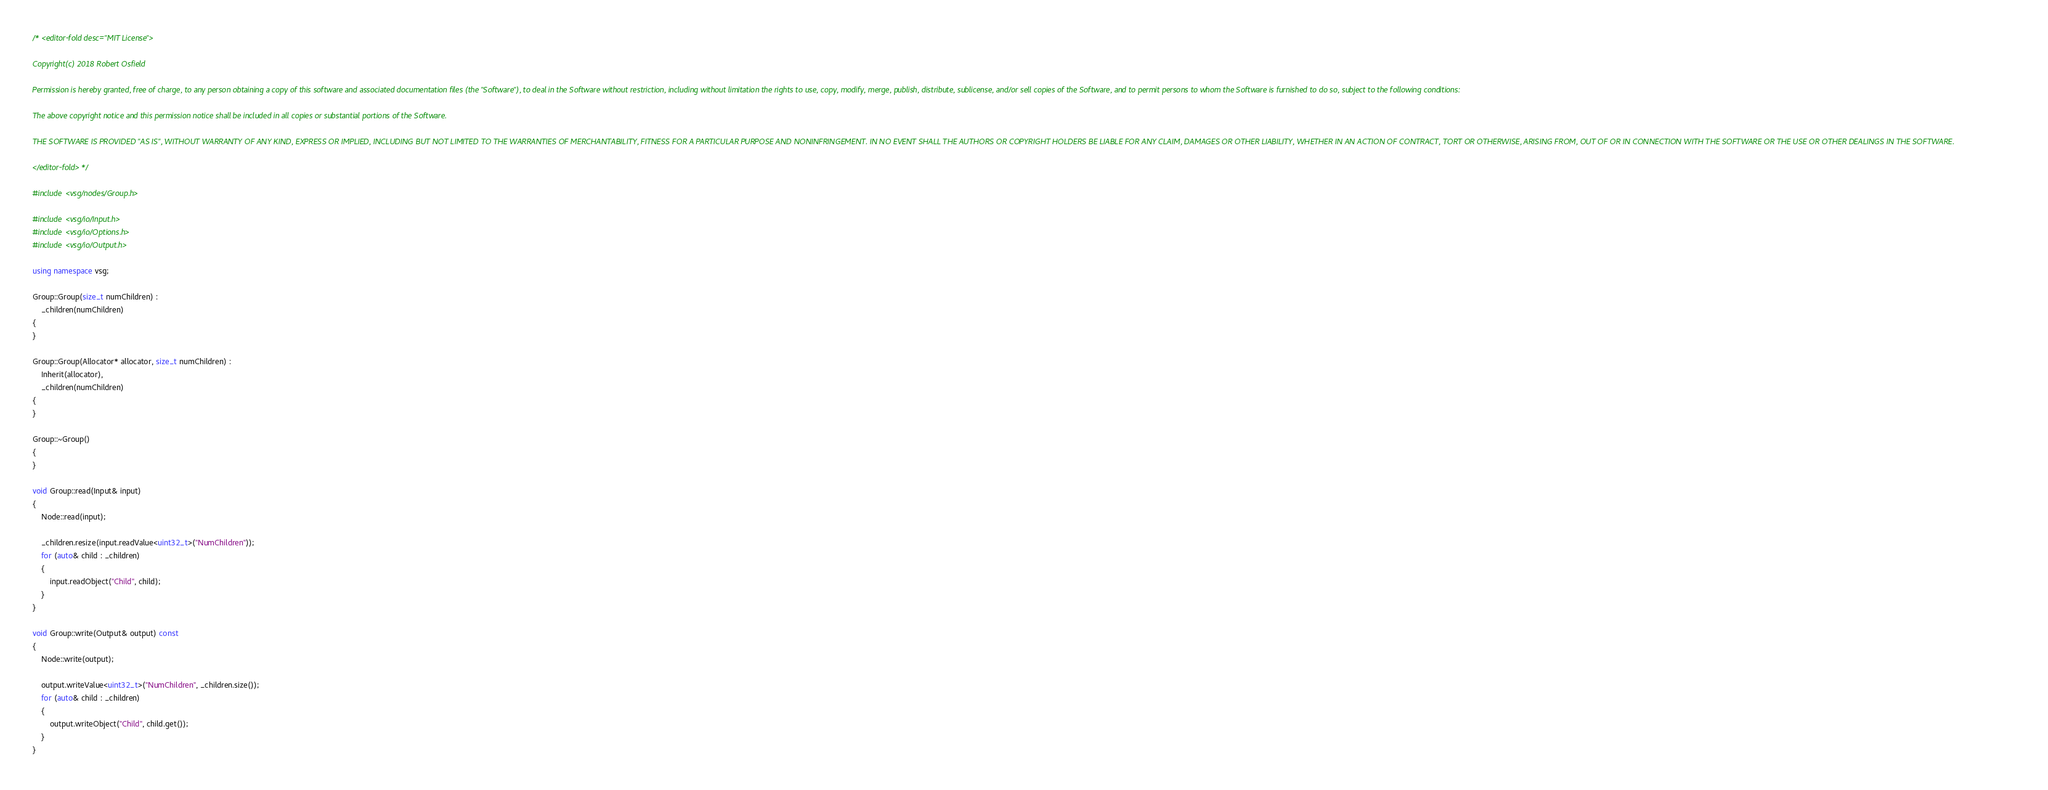<code> <loc_0><loc_0><loc_500><loc_500><_C++_>/* <editor-fold desc="MIT License">

Copyright(c) 2018 Robert Osfield

Permission is hereby granted, free of charge, to any person obtaining a copy of this software and associated documentation files (the "Software"), to deal in the Software without restriction, including without limitation the rights to use, copy, modify, merge, publish, distribute, sublicense, and/or sell copies of the Software, and to permit persons to whom the Software is furnished to do so, subject to the following conditions:

The above copyright notice and this permission notice shall be included in all copies or substantial portions of the Software.

THE SOFTWARE IS PROVIDED "AS IS", WITHOUT WARRANTY OF ANY KIND, EXPRESS OR IMPLIED, INCLUDING BUT NOT LIMITED TO THE WARRANTIES OF MERCHANTABILITY, FITNESS FOR A PARTICULAR PURPOSE AND NONINFRINGEMENT. IN NO EVENT SHALL THE AUTHORS OR COPYRIGHT HOLDERS BE LIABLE FOR ANY CLAIM, DAMAGES OR OTHER LIABILITY, WHETHER IN AN ACTION OF CONTRACT, TORT OR OTHERWISE, ARISING FROM, OUT OF OR IN CONNECTION WITH THE SOFTWARE OR THE USE OR OTHER DEALINGS IN THE SOFTWARE.

</editor-fold> */

#include <vsg/nodes/Group.h>

#include <vsg/io/Input.h>
#include <vsg/io/Options.h>
#include <vsg/io/Output.h>

using namespace vsg;

Group::Group(size_t numChildren) :
    _children(numChildren)
{
}

Group::Group(Allocator* allocator, size_t numChildren) :
    Inherit(allocator),
    _children(numChildren)
{
}

Group::~Group()
{
}

void Group::read(Input& input)
{
    Node::read(input);

    _children.resize(input.readValue<uint32_t>("NumChildren"));
    for (auto& child : _children)
    {
        input.readObject("Child", child);
    }
}

void Group::write(Output& output) const
{
    Node::write(output);

    output.writeValue<uint32_t>("NumChildren", _children.size());
    for (auto& child : _children)
    {
        output.writeObject("Child", child.get());
    }
}
</code> 